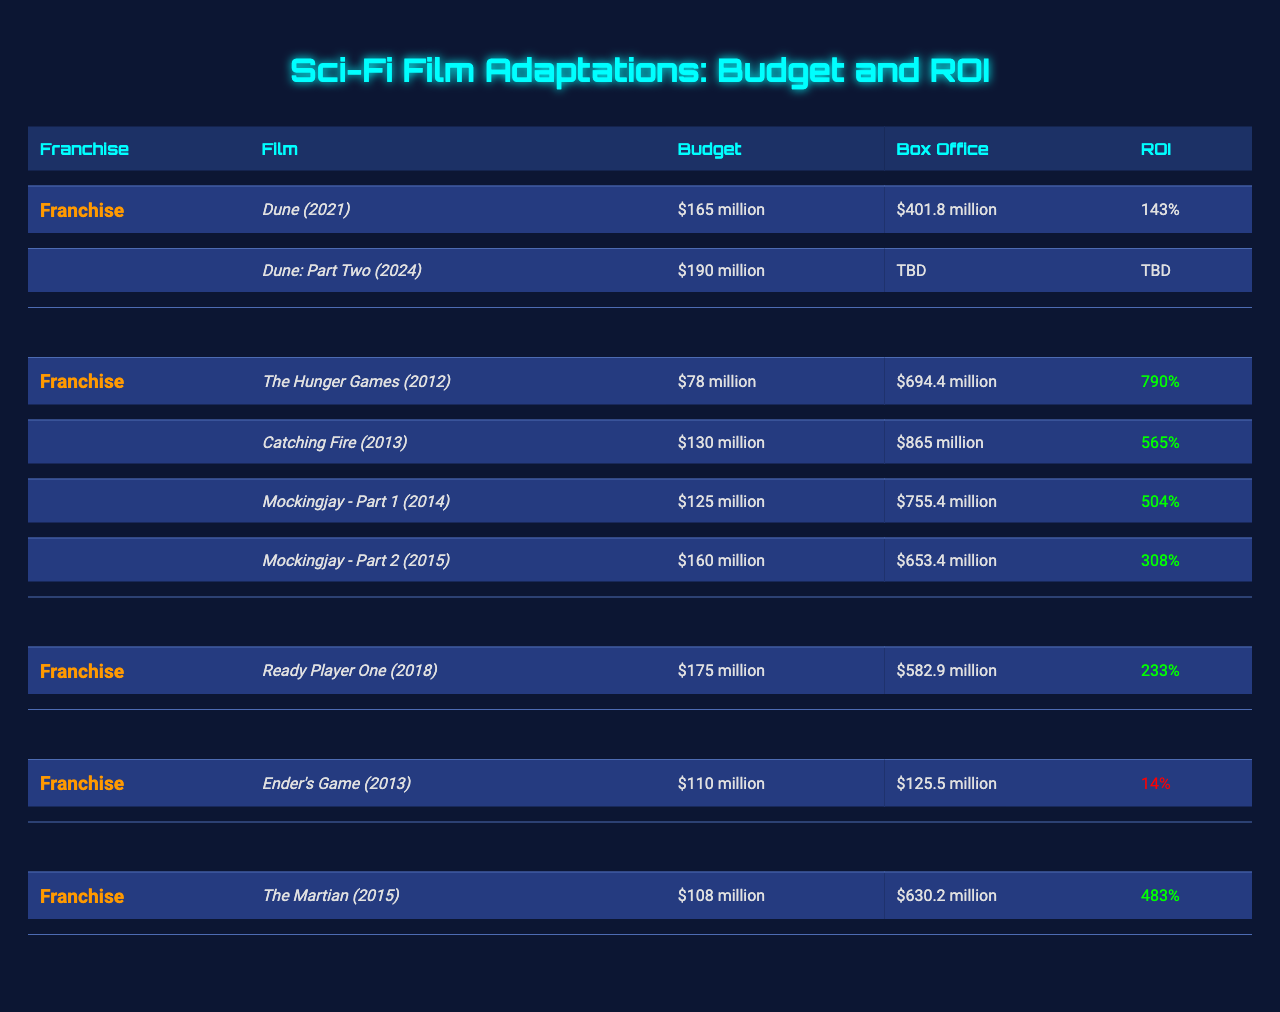What is the budget for "Dune: Part Two (2024)"? The budget for "Dune: Part Two (2024)" is listed in the table under the budget column for that specific film. It states "$190 million."
Answer: $190 million Which film has the highest Box Office return among "The Hunger Games" films? To find the highest Box Office return, we compare the Box Office figures for all the films in the franchise: $694.4 million (2012), $865 million (2013), $755.4 million (2014), and $653.4 million (2015). The highest value is $865 million from "Catching Fire (2013)."
Answer: $865 million Is the ROI for "Ender's Game (2013)" greater than 20%? The ROI for "Ender's Game (2013)" is listed as 14%. Since 14% is less than 20%, the statement is false.
Answer: No What is the average ROI for films in "The Hunger Games" franchise? To find the average ROI, we first extract the ROIs: 790%, 565%, 504%, and 308%. Adding these gives us 790 + 565 + 504 + 308 = 2167%. Dividing this sum by the number of films (4) yields an average ROI of 2167% / 4 = 541.75%.
Answer: 541.75% Which franchise shows the lowest ROI among its films? By examining the ROI values for each franchise, we note that "Ender's Game (2013)" has an ROI of 14%, which is the lowest when compared to other franchises' ROIs. Therefore, "Ender's Game" shows the lowest ROI.
Answer: Ender's Game What is the total budget for all films in "The Martian"? The total budget for "The Martian" franchise has one film listed with a budget of $108 million. Since there is only one film, the total budget is simply $108 million.
Answer: $108 million How does the ROI of "Dune (2021)" compare to the average ROI of "Ready Player One"? The ROI of "Dune (2021)" is 143%, while "Ready Player One" has an ROI of 233%. Since 233% is greater than 143%, the comparison shows that "Ready Player One" has a higher ROI than "Dune (2021)."
Answer: "Ready Player One" has a higher ROI What is the difference between the Box Office figures of "Catching Fire" and "Mockingjay - Part 1"? The Box Office for "Catching Fire" is $865 million and for "Mockingjay - Part 1" it is $755.4 million. The difference is calculated as $865 million - $755.4 million = $109.6 million.
Answer: $109.6 million How many films in the "Dune" franchise have received a release? Currently, "Dune" franchise has two films listed: "Dune (2021)" which has been released and "Dune: Part Two (2024)" which is yet to be released. Therefore, only one film has received a release.
Answer: One film 